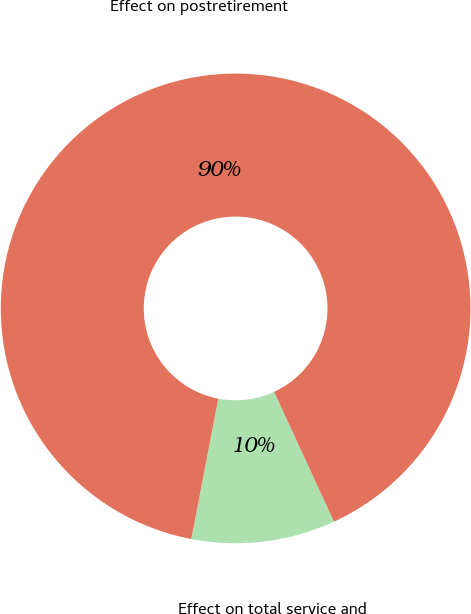Convert chart. <chart><loc_0><loc_0><loc_500><loc_500><pie_chart><fcel>Effect on total service and<fcel>Effect on postretirement<nl><fcel>9.9%<fcel>90.1%<nl></chart> 